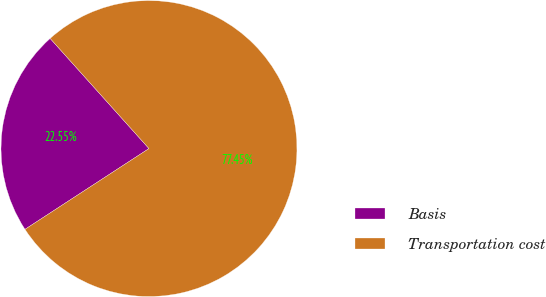<chart> <loc_0><loc_0><loc_500><loc_500><pie_chart><fcel>Basis<fcel>Transportation cost<nl><fcel>22.55%<fcel>77.45%<nl></chart> 